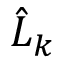Convert formula to latex. <formula><loc_0><loc_0><loc_500><loc_500>\hat { L } _ { k }</formula> 